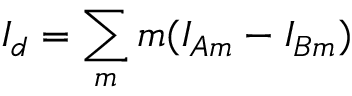<formula> <loc_0><loc_0><loc_500><loc_500>I _ { d } = \sum _ { m } m ( I _ { A m } - I _ { B m } )</formula> 